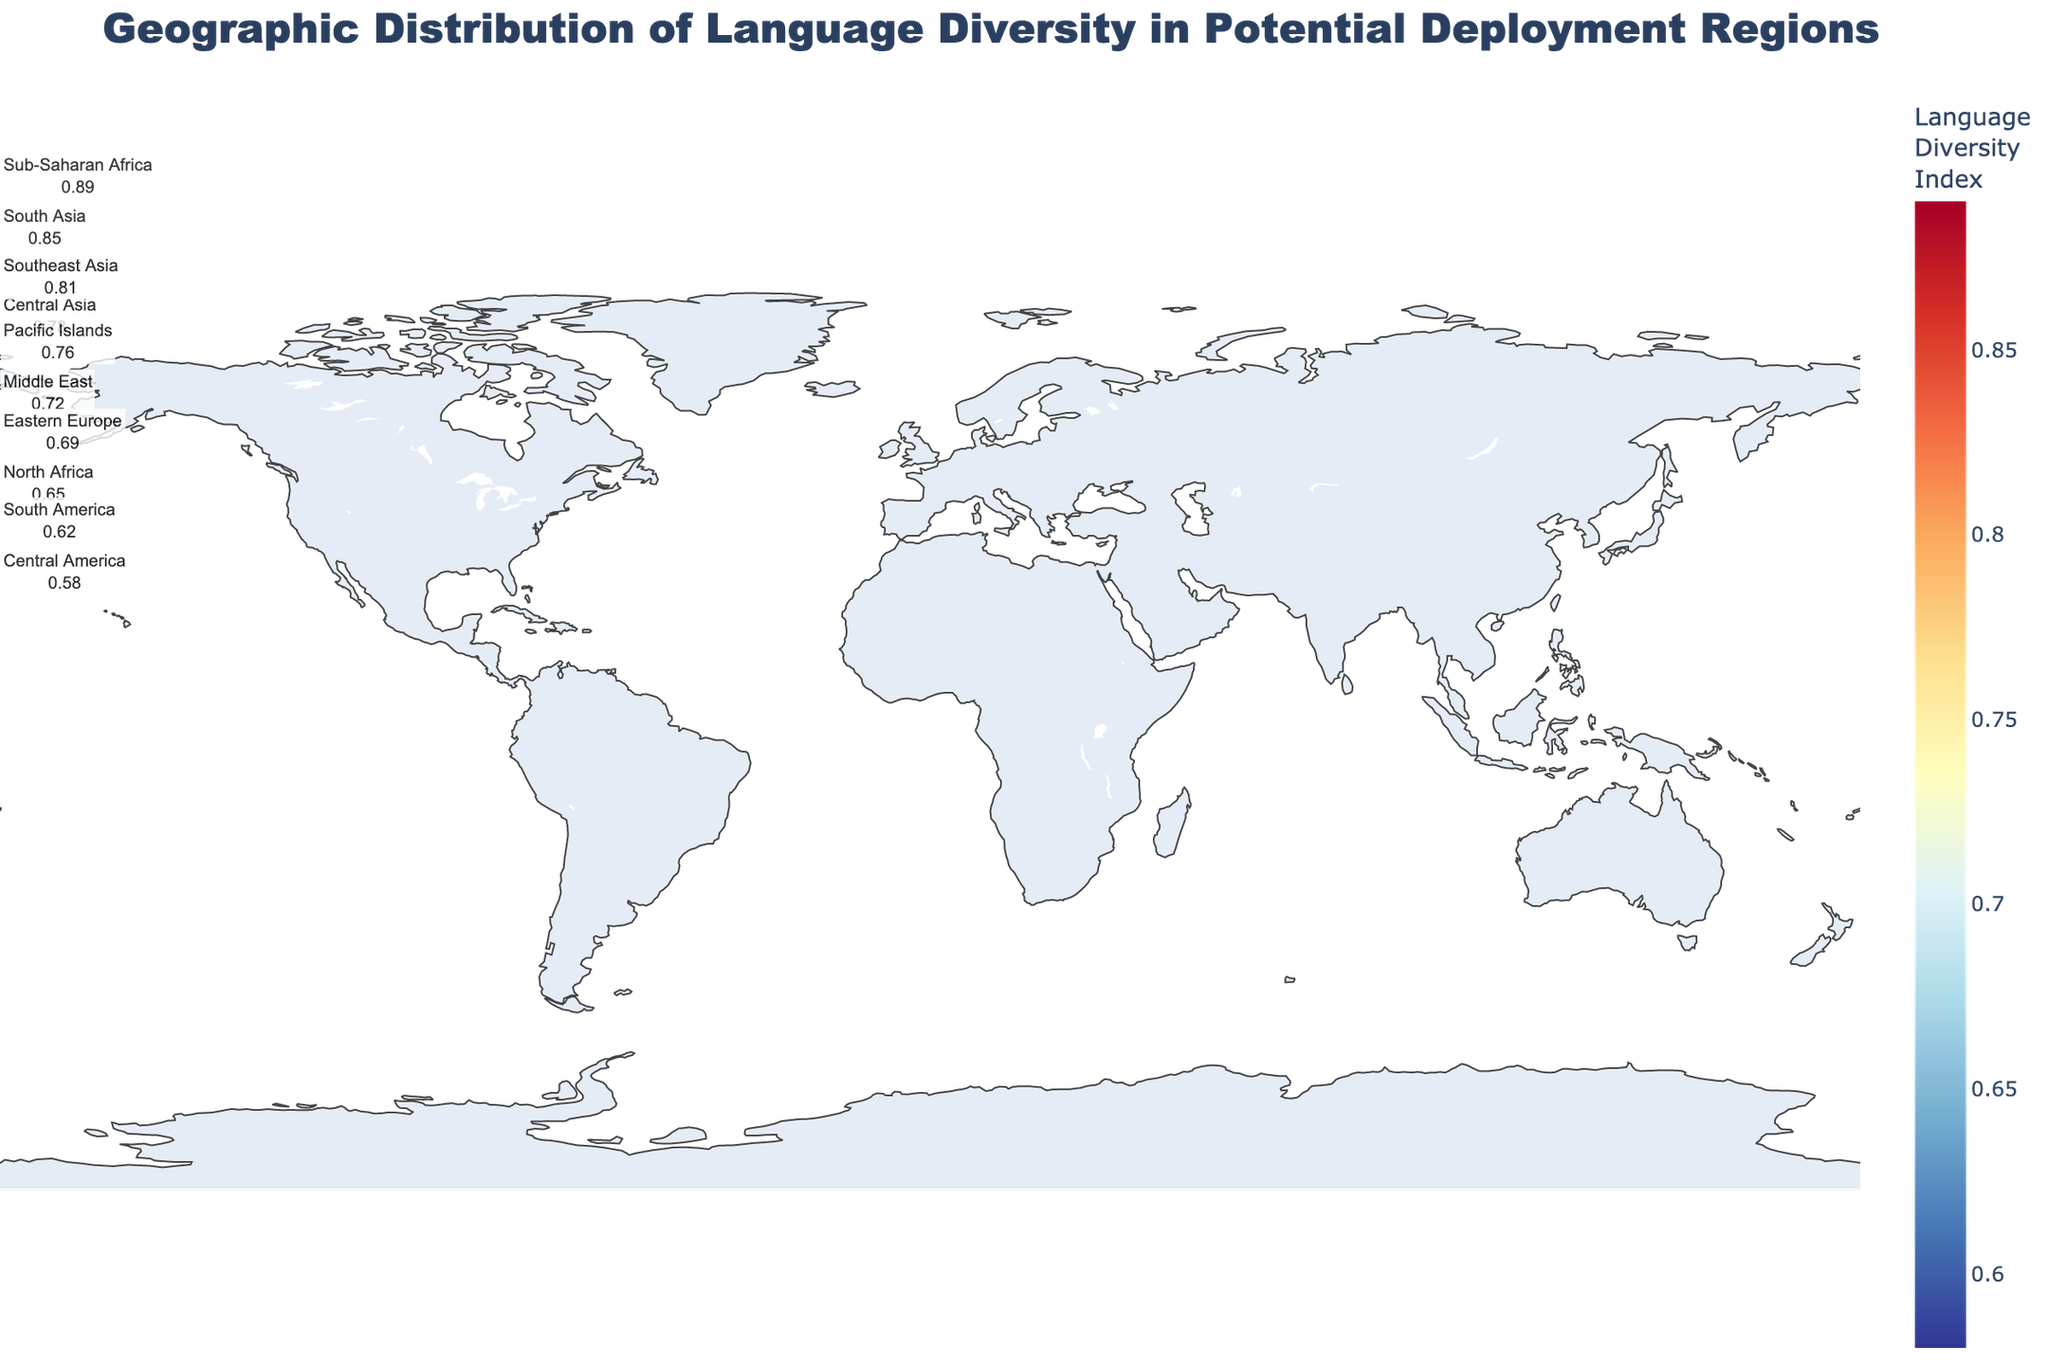Which region has the highest Language Diversity Index? To answer this, look for the region with the highest numeric value of the Language Diversity Index in the provided figure.
Answer: Sub-Saharan Africa What is the primary language spoken in Southeast Asia? Refer to the text descriptions accompanying each region's data in the figure to find the primary language listed for Southeast Asia.
Answer: Malay Compare the Language Diversity Index between South America and Central America. Which one is higher? Identify the Language Diversity Index values for both South America and Central America from the figure and compare them. South America has a value of 0.62, while Central America has a value of 0.58.
Answer: South America What's the average Language Diversity Index of North Africa and Eastern Europe? First, find the Language Diversity Index values for North Africa (0.65) and Eastern Europe (0.69). Compute the average: (0.65 + 0.69) / 2 = 0.67.
Answer: 0.67 Which three regions have the lowest Language Diversity Index, and what are their values? Examine the figure for the three lowest values of the Language Diversity Index and identify the corresponding regions and their values. Central America (0.58), South America (0.62), and North Africa (0.65).
Answer: Central America (0.58), South America (0.62), North Africa (0.65) Is the Language Diversity Index of Central Asia greater than that of the Middle East? Check the values of the Language Diversity Index for Central Asia (0.78) and the Middle East (0.72) and compare them.
Answer: Yes Calculate the difference in Language Diversity Index between South Asia and South America. Subtract the Language Diversity Index of South America (0.62) from South Asia (0.85): 0.85 - 0.62 = 0.23.
Answer: 0.23 Which region has a primary language that is also a secondary language in another region? Identify any primary language listed in one region that appears as a secondary language in another region. For example, Arabic is the primary language in the Middle East and the secondary language in North Africa.
Answer: Arabic 